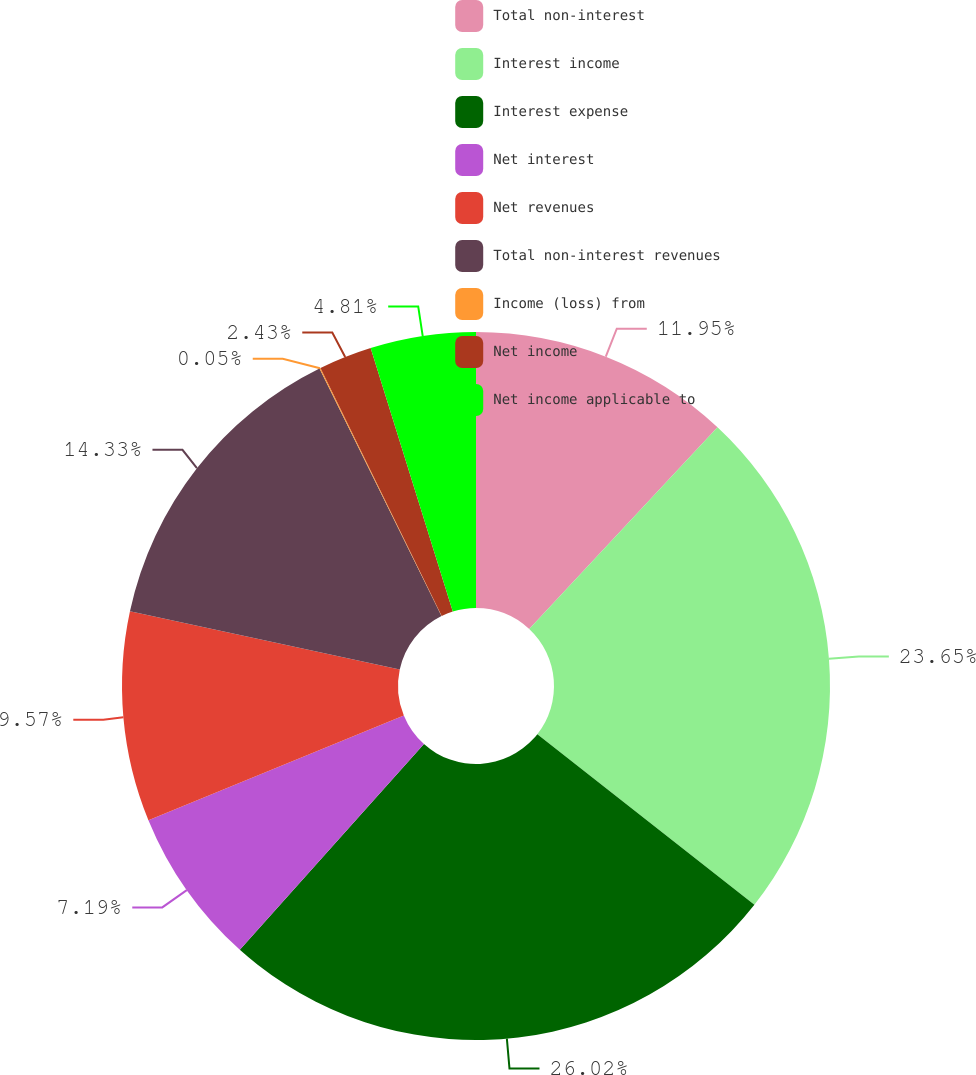Convert chart to OTSL. <chart><loc_0><loc_0><loc_500><loc_500><pie_chart><fcel>Total non-interest<fcel>Interest income<fcel>Interest expense<fcel>Net interest<fcel>Net revenues<fcel>Total non-interest revenues<fcel>Income (loss) from<fcel>Net income<fcel>Net income applicable to<nl><fcel>11.95%<fcel>23.65%<fcel>26.03%<fcel>7.19%<fcel>9.57%<fcel>14.33%<fcel>0.05%<fcel>2.43%<fcel>4.81%<nl></chart> 